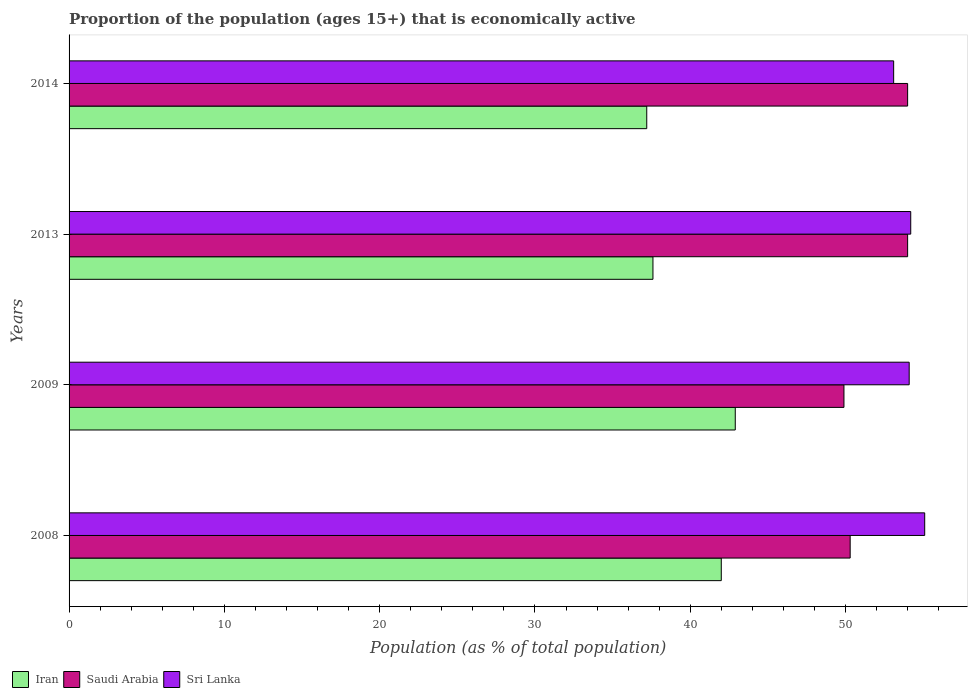How many different coloured bars are there?
Offer a very short reply. 3. How many groups of bars are there?
Give a very brief answer. 4. Are the number of bars on each tick of the Y-axis equal?
Give a very brief answer. Yes. How many bars are there on the 2nd tick from the bottom?
Keep it short and to the point. 3. What is the label of the 3rd group of bars from the top?
Provide a short and direct response. 2009. What is the proportion of the population that is economically active in Sri Lanka in 2008?
Your answer should be compact. 55.1. Across all years, what is the maximum proportion of the population that is economically active in Iran?
Ensure brevity in your answer.  42.9. Across all years, what is the minimum proportion of the population that is economically active in Iran?
Ensure brevity in your answer.  37.2. What is the total proportion of the population that is economically active in Iran in the graph?
Offer a very short reply. 159.7. What is the difference between the proportion of the population that is economically active in Sri Lanka in 2008 and the proportion of the population that is economically active in Iran in 2013?
Ensure brevity in your answer.  17.5. What is the average proportion of the population that is economically active in Saudi Arabia per year?
Your answer should be very brief. 52.05. In the year 2014, what is the difference between the proportion of the population that is economically active in Iran and proportion of the population that is economically active in Saudi Arabia?
Ensure brevity in your answer.  -16.8. What is the ratio of the proportion of the population that is economically active in Sri Lanka in 2008 to that in 2009?
Your response must be concise. 1.02. Is the proportion of the population that is economically active in Sri Lanka in 2009 less than that in 2013?
Provide a succinct answer. Yes. Is the difference between the proportion of the population that is economically active in Iran in 2008 and 2013 greater than the difference between the proportion of the population that is economically active in Saudi Arabia in 2008 and 2013?
Your answer should be very brief. Yes. What is the difference between the highest and the second highest proportion of the population that is economically active in Iran?
Your answer should be very brief. 0.9. What is the difference between the highest and the lowest proportion of the population that is economically active in Iran?
Your answer should be very brief. 5.7. In how many years, is the proportion of the population that is economically active in Sri Lanka greater than the average proportion of the population that is economically active in Sri Lanka taken over all years?
Provide a short and direct response. 2. Is the sum of the proportion of the population that is economically active in Sri Lanka in 2008 and 2009 greater than the maximum proportion of the population that is economically active in Saudi Arabia across all years?
Ensure brevity in your answer.  Yes. What does the 2nd bar from the top in 2014 represents?
Your answer should be compact. Saudi Arabia. What does the 1st bar from the bottom in 2009 represents?
Provide a succinct answer. Iran. How many bars are there?
Ensure brevity in your answer.  12. Are all the bars in the graph horizontal?
Your answer should be very brief. Yes. How many years are there in the graph?
Keep it short and to the point. 4. What is the difference between two consecutive major ticks on the X-axis?
Make the answer very short. 10. Does the graph contain grids?
Offer a terse response. No. Where does the legend appear in the graph?
Ensure brevity in your answer.  Bottom left. What is the title of the graph?
Ensure brevity in your answer.  Proportion of the population (ages 15+) that is economically active. What is the label or title of the X-axis?
Make the answer very short. Population (as % of total population). What is the Population (as % of total population) in Iran in 2008?
Your answer should be compact. 42. What is the Population (as % of total population) of Saudi Arabia in 2008?
Ensure brevity in your answer.  50.3. What is the Population (as % of total population) of Sri Lanka in 2008?
Provide a short and direct response. 55.1. What is the Population (as % of total population) of Iran in 2009?
Provide a succinct answer. 42.9. What is the Population (as % of total population) of Saudi Arabia in 2009?
Offer a very short reply. 49.9. What is the Population (as % of total population) of Sri Lanka in 2009?
Make the answer very short. 54.1. What is the Population (as % of total population) of Iran in 2013?
Your response must be concise. 37.6. What is the Population (as % of total population) of Saudi Arabia in 2013?
Offer a terse response. 54. What is the Population (as % of total population) of Sri Lanka in 2013?
Your response must be concise. 54.2. What is the Population (as % of total population) in Iran in 2014?
Make the answer very short. 37.2. What is the Population (as % of total population) in Sri Lanka in 2014?
Give a very brief answer. 53.1. Across all years, what is the maximum Population (as % of total population) of Iran?
Your answer should be very brief. 42.9. Across all years, what is the maximum Population (as % of total population) of Saudi Arabia?
Ensure brevity in your answer.  54. Across all years, what is the maximum Population (as % of total population) of Sri Lanka?
Your response must be concise. 55.1. Across all years, what is the minimum Population (as % of total population) in Iran?
Keep it short and to the point. 37.2. Across all years, what is the minimum Population (as % of total population) of Saudi Arabia?
Your response must be concise. 49.9. Across all years, what is the minimum Population (as % of total population) of Sri Lanka?
Your answer should be compact. 53.1. What is the total Population (as % of total population) of Iran in the graph?
Your response must be concise. 159.7. What is the total Population (as % of total population) of Saudi Arabia in the graph?
Provide a succinct answer. 208.2. What is the total Population (as % of total population) in Sri Lanka in the graph?
Your answer should be compact. 216.5. What is the difference between the Population (as % of total population) of Iran in 2008 and that in 2009?
Give a very brief answer. -0.9. What is the difference between the Population (as % of total population) in Saudi Arabia in 2008 and that in 2009?
Offer a very short reply. 0.4. What is the difference between the Population (as % of total population) of Sri Lanka in 2008 and that in 2009?
Provide a succinct answer. 1. What is the difference between the Population (as % of total population) in Iran in 2008 and that in 2013?
Give a very brief answer. 4.4. What is the difference between the Population (as % of total population) of Sri Lanka in 2008 and that in 2013?
Your answer should be compact. 0.9. What is the difference between the Population (as % of total population) of Iran in 2008 and that in 2014?
Offer a very short reply. 4.8. What is the difference between the Population (as % of total population) in Saudi Arabia in 2008 and that in 2014?
Keep it short and to the point. -3.7. What is the difference between the Population (as % of total population) in Sri Lanka in 2009 and that in 2013?
Keep it short and to the point. -0.1. What is the difference between the Population (as % of total population) of Iran in 2009 and that in 2014?
Provide a short and direct response. 5.7. What is the difference between the Population (as % of total population) of Saudi Arabia in 2009 and that in 2014?
Provide a short and direct response. -4.1. What is the difference between the Population (as % of total population) in Sri Lanka in 2009 and that in 2014?
Your answer should be compact. 1. What is the difference between the Population (as % of total population) of Iran in 2008 and the Population (as % of total population) of Saudi Arabia in 2014?
Offer a very short reply. -12. What is the difference between the Population (as % of total population) of Saudi Arabia in 2008 and the Population (as % of total population) of Sri Lanka in 2014?
Your answer should be compact. -2.8. What is the difference between the Population (as % of total population) in Iran in 2009 and the Population (as % of total population) in Sri Lanka in 2013?
Your answer should be compact. -11.3. What is the difference between the Population (as % of total population) of Iran in 2009 and the Population (as % of total population) of Saudi Arabia in 2014?
Ensure brevity in your answer.  -11.1. What is the difference between the Population (as % of total population) in Iran in 2009 and the Population (as % of total population) in Sri Lanka in 2014?
Ensure brevity in your answer.  -10.2. What is the difference between the Population (as % of total population) of Iran in 2013 and the Population (as % of total population) of Saudi Arabia in 2014?
Your response must be concise. -16.4. What is the difference between the Population (as % of total population) in Iran in 2013 and the Population (as % of total population) in Sri Lanka in 2014?
Make the answer very short. -15.5. What is the average Population (as % of total population) of Iran per year?
Offer a very short reply. 39.92. What is the average Population (as % of total population) in Saudi Arabia per year?
Your response must be concise. 52.05. What is the average Population (as % of total population) of Sri Lanka per year?
Make the answer very short. 54.12. In the year 2008, what is the difference between the Population (as % of total population) in Iran and Population (as % of total population) in Saudi Arabia?
Keep it short and to the point. -8.3. In the year 2008, what is the difference between the Population (as % of total population) in Iran and Population (as % of total population) in Sri Lanka?
Your answer should be compact. -13.1. In the year 2009, what is the difference between the Population (as % of total population) in Iran and Population (as % of total population) in Saudi Arabia?
Ensure brevity in your answer.  -7. In the year 2013, what is the difference between the Population (as % of total population) in Iran and Population (as % of total population) in Saudi Arabia?
Give a very brief answer. -16.4. In the year 2013, what is the difference between the Population (as % of total population) in Iran and Population (as % of total population) in Sri Lanka?
Your answer should be very brief. -16.6. In the year 2013, what is the difference between the Population (as % of total population) in Saudi Arabia and Population (as % of total population) in Sri Lanka?
Offer a terse response. -0.2. In the year 2014, what is the difference between the Population (as % of total population) in Iran and Population (as % of total population) in Saudi Arabia?
Offer a very short reply. -16.8. In the year 2014, what is the difference between the Population (as % of total population) of Iran and Population (as % of total population) of Sri Lanka?
Give a very brief answer. -15.9. In the year 2014, what is the difference between the Population (as % of total population) in Saudi Arabia and Population (as % of total population) in Sri Lanka?
Offer a terse response. 0.9. What is the ratio of the Population (as % of total population) of Iran in 2008 to that in 2009?
Provide a short and direct response. 0.98. What is the ratio of the Population (as % of total population) of Sri Lanka in 2008 to that in 2009?
Your answer should be compact. 1.02. What is the ratio of the Population (as % of total population) of Iran in 2008 to that in 2013?
Provide a succinct answer. 1.12. What is the ratio of the Population (as % of total population) of Saudi Arabia in 2008 to that in 2013?
Ensure brevity in your answer.  0.93. What is the ratio of the Population (as % of total population) of Sri Lanka in 2008 to that in 2013?
Ensure brevity in your answer.  1.02. What is the ratio of the Population (as % of total population) of Iran in 2008 to that in 2014?
Your response must be concise. 1.13. What is the ratio of the Population (as % of total population) of Saudi Arabia in 2008 to that in 2014?
Make the answer very short. 0.93. What is the ratio of the Population (as % of total population) in Sri Lanka in 2008 to that in 2014?
Provide a short and direct response. 1.04. What is the ratio of the Population (as % of total population) in Iran in 2009 to that in 2013?
Provide a short and direct response. 1.14. What is the ratio of the Population (as % of total population) in Saudi Arabia in 2009 to that in 2013?
Offer a very short reply. 0.92. What is the ratio of the Population (as % of total population) of Iran in 2009 to that in 2014?
Offer a terse response. 1.15. What is the ratio of the Population (as % of total population) of Saudi Arabia in 2009 to that in 2014?
Provide a succinct answer. 0.92. What is the ratio of the Population (as % of total population) of Sri Lanka in 2009 to that in 2014?
Your response must be concise. 1.02. What is the ratio of the Population (as % of total population) in Iran in 2013 to that in 2014?
Your answer should be very brief. 1.01. What is the ratio of the Population (as % of total population) of Sri Lanka in 2013 to that in 2014?
Offer a very short reply. 1.02. What is the difference between the highest and the second highest Population (as % of total population) of Iran?
Make the answer very short. 0.9. 